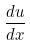<formula> <loc_0><loc_0><loc_500><loc_500>\frac { d u } { d x }</formula> 